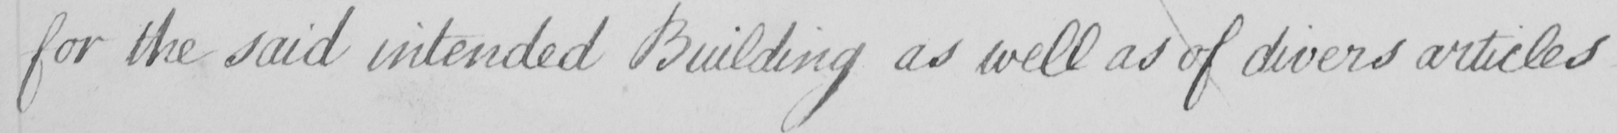Please provide the text content of this handwritten line. for the said intended Building as well as of divers articles  _ 